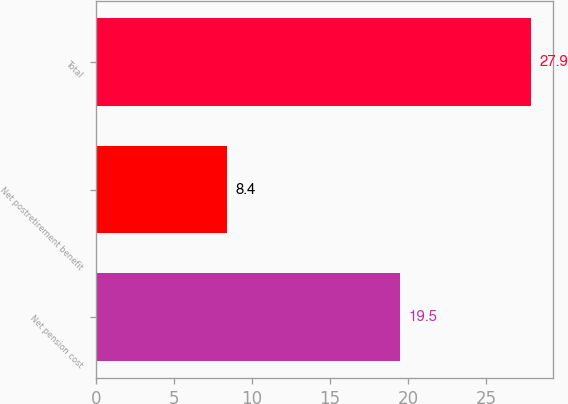<chart> <loc_0><loc_0><loc_500><loc_500><bar_chart><fcel>Net pension cost<fcel>Net postretirement benefit<fcel>Total<nl><fcel>19.5<fcel>8.4<fcel>27.9<nl></chart> 